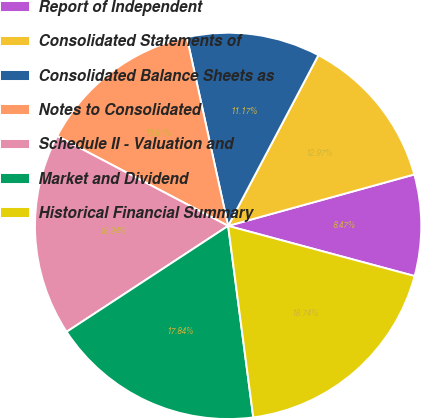<chart> <loc_0><loc_0><loc_500><loc_500><pie_chart><fcel>Report of Independent<fcel>Consolidated Statements of<fcel>Consolidated Balance Sheets as<fcel>Notes to Consolidated<fcel>Schedule II - Valuation and<fcel>Market and Dividend<fcel>Historical Financial Summary<nl><fcel>8.47%<fcel>12.97%<fcel>11.17%<fcel>13.87%<fcel>16.94%<fcel>17.84%<fcel>18.74%<nl></chart> 